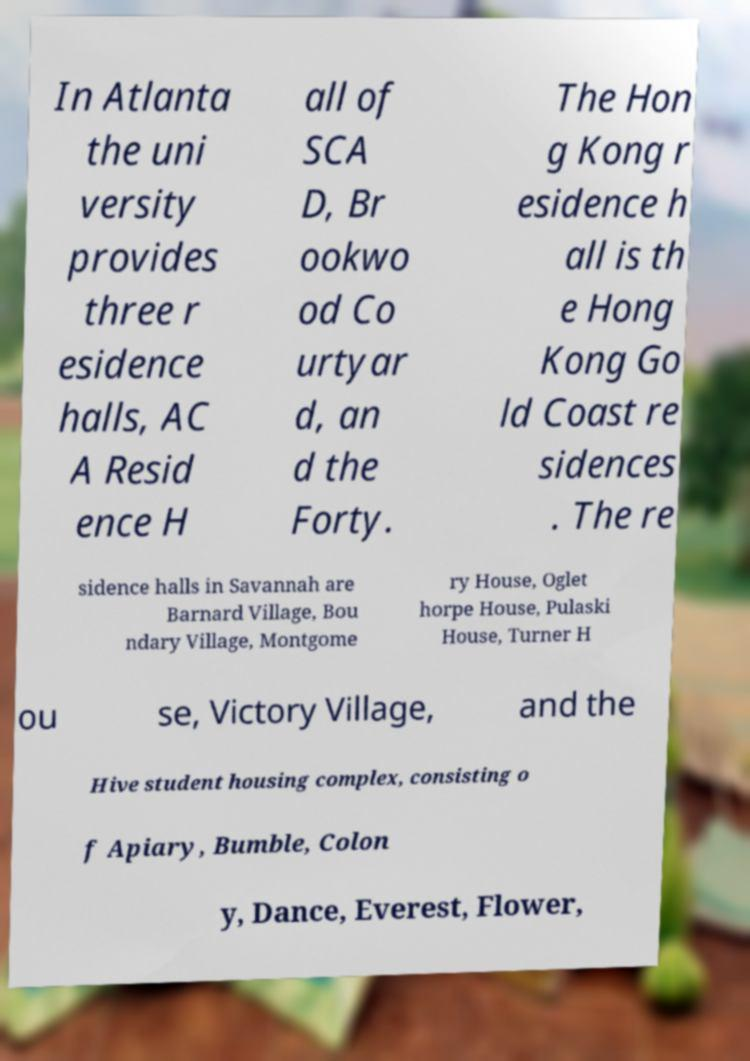Please identify and transcribe the text found in this image. In Atlanta the uni versity provides three r esidence halls, AC A Resid ence H all of SCA D, Br ookwo od Co urtyar d, an d the Forty. The Hon g Kong r esidence h all is th e Hong Kong Go ld Coast re sidences . The re sidence halls in Savannah are Barnard Village, Bou ndary Village, Montgome ry House, Oglet horpe House, Pulaski House, Turner H ou se, Victory Village, and the Hive student housing complex, consisting o f Apiary, Bumble, Colon y, Dance, Everest, Flower, 